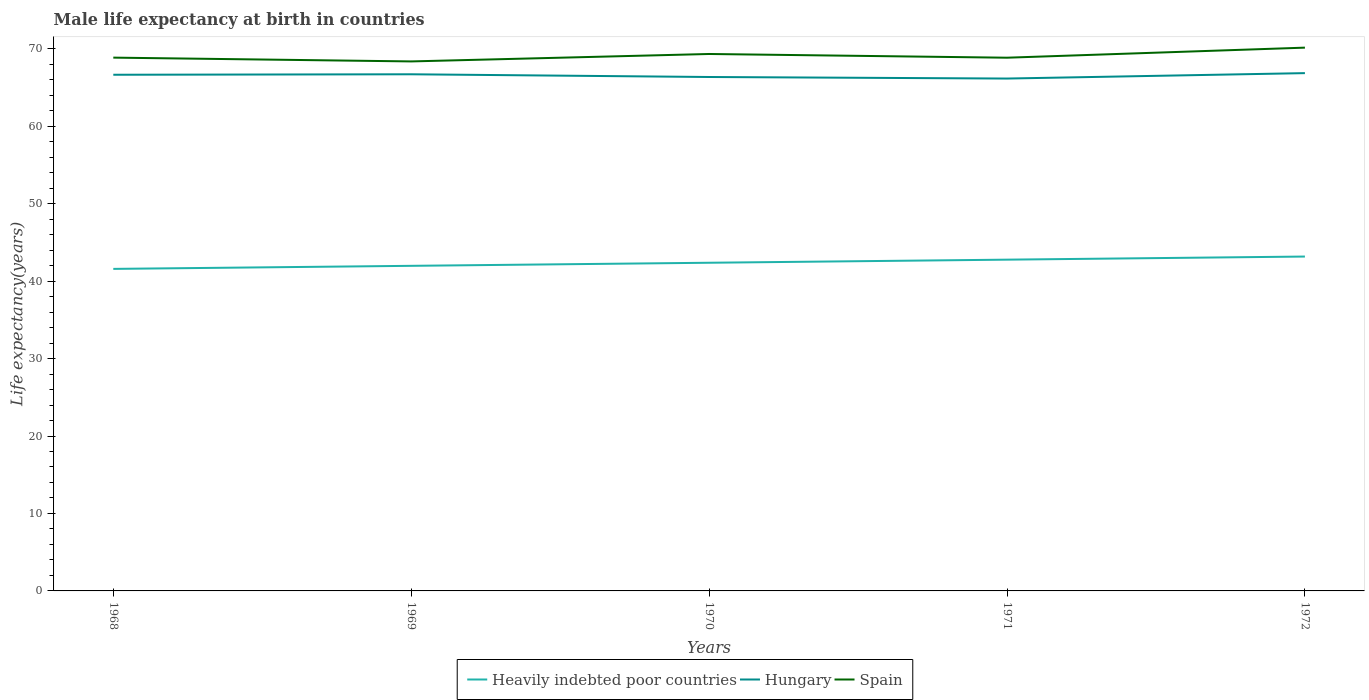Is the number of lines equal to the number of legend labels?
Make the answer very short. Yes. Across all years, what is the maximum male life expectancy at birth in Spain?
Offer a very short reply. 68.36. In which year was the male life expectancy at birth in Heavily indebted poor countries maximum?
Make the answer very short. 1968. What is the total male life expectancy at birth in Hungary in the graph?
Offer a very short reply. -0.15. What is the difference between the highest and the second highest male life expectancy at birth in Heavily indebted poor countries?
Keep it short and to the point. 1.59. What is the difference between the highest and the lowest male life expectancy at birth in Spain?
Provide a short and direct response. 2. Is the male life expectancy at birth in Heavily indebted poor countries strictly greater than the male life expectancy at birth in Spain over the years?
Provide a short and direct response. Yes. How many lines are there?
Provide a short and direct response. 3. How many years are there in the graph?
Your answer should be compact. 5. What is the difference between two consecutive major ticks on the Y-axis?
Provide a succinct answer. 10. Does the graph contain any zero values?
Your answer should be compact. No. Does the graph contain grids?
Give a very brief answer. No. Where does the legend appear in the graph?
Ensure brevity in your answer.  Bottom center. How many legend labels are there?
Offer a very short reply. 3. What is the title of the graph?
Keep it short and to the point. Male life expectancy at birth in countries. Does "Euro area" appear as one of the legend labels in the graph?
Keep it short and to the point. No. What is the label or title of the Y-axis?
Provide a succinct answer. Life expectancy(years). What is the Life expectancy(years) in Heavily indebted poor countries in 1968?
Make the answer very short. 41.58. What is the Life expectancy(years) in Hungary in 1968?
Provide a succinct answer. 66.64. What is the Life expectancy(years) in Spain in 1968?
Ensure brevity in your answer.  68.85. What is the Life expectancy(years) of Heavily indebted poor countries in 1969?
Make the answer very short. 41.97. What is the Life expectancy(years) in Hungary in 1969?
Your answer should be very brief. 66.7. What is the Life expectancy(years) of Spain in 1969?
Your answer should be very brief. 68.36. What is the Life expectancy(years) of Heavily indebted poor countries in 1970?
Provide a succinct answer. 42.37. What is the Life expectancy(years) of Hungary in 1970?
Ensure brevity in your answer.  66.35. What is the Life expectancy(years) in Spain in 1970?
Keep it short and to the point. 69.32. What is the Life expectancy(years) of Heavily indebted poor countries in 1971?
Offer a very short reply. 42.77. What is the Life expectancy(years) in Hungary in 1971?
Ensure brevity in your answer.  66.15. What is the Life expectancy(years) in Spain in 1971?
Provide a short and direct response. 68.84. What is the Life expectancy(years) in Heavily indebted poor countries in 1972?
Make the answer very short. 43.17. What is the Life expectancy(years) of Hungary in 1972?
Your answer should be compact. 66.85. What is the Life expectancy(years) of Spain in 1972?
Make the answer very short. 70.14. Across all years, what is the maximum Life expectancy(years) in Heavily indebted poor countries?
Provide a short and direct response. 43.17. Across all years, what is the maximum Life expectancy(years) of Hungary?
Make the answer very short. 66.85. Across all years, what is the maximum Life expectancy(years) of Spain?
Offer a very short reply. 70.14. Across all years, what is the minimum Life expectancy(years) in Heavily indebted poor countries?
Offer a terse response. 41.58. Across all years, what is the minimum Life expectancy(years) of Hungary?
Offer a terse response. 66.15. Across all years, what is the minimum Life expectancy(years) of Spain?
Give a very brief answer. 68.36. What is the total Life expectancy(years) of Heavily indebted poor countries in the graph?
Provide a short and direct response. 211.85. What is the total Life expectancy(years) of Hungary in the graph?
Your response must be concise. 332.69. What is the total Life expectancy(years) of Spain in the graph?
Ensure brevity in your answer.  345.51. What is the difference between the Life expectancy(years) in Heavily indebted poor countries in 1968 and that in 1969?
Give a very brief answer. -0.4. What is the difference between the Life expectancy(years) in Hungary in 1968 and that in 1969?
Keep it short and to the point. -0.06. What is the difference between the Life expectancy(years) in Spain in 1968 and that in 1969?
Your answer should be very brief. 0.49. What is the difference between the Life expectancy(years) of Heavily indebted poor countries in 1968 and that in 1970?
Offer a terse response. -0.79. What is the difference between the Life expectancy(years) of Hungary in 1968 and that in 1970?
Ensure brevity in your answer.  0.29. What is the difference between the Life expectancy(years) in Spain in 1968 and that in 1970?
Make the answer very short. -0.47. What is the difference between the Life expectancy(years) of Heavily indebted poor countries in 1968 and that in 1971?
Offer a very short reply. -1.19. What is the difference between the Life expectancy(years) of Hungary in 1968 and that in 1971?
Provide a succinct answer. 0.49. What is the difference between the Life expectancy(years) in Heavily indebted poor countries in 1968 and that in 1972?
Keep it short and to the point. -1.59. What is the difference between the Life expectancy(years) in Hungary in 1968 and that in 1972?
Give a very brief answer. -0.21. What is the difference between the Life expectancy(years) of Spain in 1968 and that in 1972?
Provide a succinct answer. -1.29. What is the difference between the Life expectancy(years) of Heavily indebted poor countries in 1969 and that in 1970?
Your response must be concise. -0.4. What is the difference between the Life expectancy(years) in Spain in 1969 and that in 1970?
Make the answer very short. -0.96. What is the difference between the Life expectancy(years) of Heavily indebted poor countries in 1969 and that in 1971?
Provide a short and direct response. -0.8. What is the difference between the Life expectancy(years) of Hungary in 1969 and that in 1971?
Give a very brief answer. 0.55. What is the difference between the Life expectancy(years) of Spain in 1969 and that in 1971?
Make the answer very short. -0.48. What is the difference between the Life expectancy(years) in Heavily indebted poor countries in 1969 and that in 1972?
Your response must be concise. -1.2. What is the difference between the Life expectancy(years) in Hungary in 1969 and that in 1972?
Your response must be concise. -0.15. What is the difference between the Life expectancy(years) of Spain in 1969 and that in 1972?
Offer a terse response. -1.78. What is the difference between the Life expectancy(years) of Heavily indebted poor countries in 1970 and that in 1971?
Keep it short and to the point. -0.4. What is the difference between the Life expectancy(years) of Spain in 1970 and that in 1971?
Your answer should be very brief. 0.48. What is the difference between the Life expectancy(years) in Heavily indebted poor countries in 1970 and that in 1972?
Give a very brief answer. -0.8. What is the difference between the Life expectancy(years) in Hungary in 1970 and that in 1972?
Ensure brevity in your answer.  -0.5. What is the difference between the Life expectancy(years) in Spain in 1970 and that in 1972?
Your answer should be compact. -0.82. What is the difference between the Life expectancy(years) of Heavily indebted poor countries in 1971 and that in 1972?
Offer a very short reply. -0.4. What is the difference between the Life expectancy(years) in Spain in 1971 and that in 1972?
Your response must be concise. -1.3. What is the difference between the Life expectancy(years) of Heavily indebted poor countries in 1968 and the Life expectancy(years) of Hungary in 1969?
Your response must be concise. -25.12. What is the difference between the Life expectancy(years) of Heavily indebted poor countries in 1968 and the Life expectancy(years) of Spain in 1969?
Make the answer very short. -26.78. What is the difference between the Life expectancy(years) of Hungary in 1968 and the Life expectancy(years) of Spain in 1969?
Offer a terse response. -1.72. What is the difference between the Life expectancy(years) of Heavily indebted poor countries in 1968 and the Life expectancy(years) of Hungary in 1970?
Provide a short and direct response. -24.77. What is the difference between the Life expectancy(years) of Heavily indebted poor countries in 1968 and the Life expectancy(years) of Spain in 1970?
Provide a short and direct response. -27.74. What is the difference between the Life expectancy(years) of Hungary in 1968 and the Life expectancy(years) of Spain in 1970?
Your answer should be compact. -2.68. What is the difference between the Life expectancy(years) of Heavily indebted poor countries in 1968 and the Life expectancy(years) of Hungary in 1971?
Keep it short and to the point. -24.57. What is the difference between the Life expectancy(years) in Heavily indebted poor countries in 1968 and the Life expectancy(years) in Spain in 1971?
Keep it short and to the point. -27.26. What is the difference between the Life expectancy(years) of Hungary in 1968 and the Life expectancy(years) of Spain in 1971?
Keep it short and to the point. -2.2. What is the difference between the Life expectancy(years) of Heavily indebted poor countries in 1968 and the Life expectancy(years) of Hungary in 1972?
Offer a terse response. -25.27. What is the difference between the Life expectancy(years) of Heavily indebted poor countries in 1968 and the Life expectancy(years) of Spain in 1972?
Provide a succinct answer. -28.56. What is the difference between the Life expectancy(years) in Hungary in 1968 and the Life expectancy(years) in Spain in 1972?
Ensure brevity in your answer.  -3.5. What is the difference between the Life expectancy(years) in Heavily indebted poor countries in 1969 and the Life expectancy(years) in Hungary in 1970?
Offer a terse response. -24.38. What is the difference between the Life expectancy(years) of Heavily indebted poor countries in 1969 and the Life expectancy(years) of Spain in 1970?
Your response must be concise. -27.35. What is the difference between the Life expectancy(years) of Hungary in 1969 and the Life expectancy(years) of Spain in 1970?
Your answer should be very brief. -2.62. What is the difference between the Life expectancy(years) in Heavily indebted poor countries in 1969 and the Life expectancy(years) in Hungary in 1971?
Make the answer very short. -24.18. What is the difference between the Life expectancy(years) of Heavily indebted poor countries in 1969 and the Life expectancy(years) of Spain in 1971?
Your response must be concise. -26.87. What is the difference between the Life expectancy(years) in Hungary in 1969 and the Life expectancy(years) in Spain in 1971?
Provide a short and direct response. -2.14. What is the difference between the Life expectancy(years) of Heavily indebted poor countries in 1969 and the Life expectancy(years) of Hungary in 1972?
Make the answer very short. -24.88. What is the difference between the Life expectancy(years) in Heavily indebted poor countries in 1969 and the Life expectancy(years) in Spain in 1972?
Your answer should be compact. -28.17. What is the difference between the Life expectancy(years) of Hungary in 1969 and the Life expectancy(years) of Spain in 1972?
Offer a very short reply. -3.44. What is the difference between the Life expectancy(years) in Heavily indebted poor countries in 1970 and the Life expectancy(years) in Hungary in 1971?
Give a very brief answer. -23.78. What is the difference between the Life expectancy(years) of Heavily indebted poor countries in 1970 and the Life expectancy(years) of Spain in 1971?
Provide a short and direct response. -26.47. What is the difference between the Life expectancy(years) in Hungary in 1970 and the Life expectancy(years) in Spain in 1971?
Offer a very short reply. -2.49. What is the difference between the Life expectancy(years) in Heavily indebted poor countries in 1970 and the Life expectancy(years) in Hungary in 1972?
Provide a succinct answer. -24.48. What is the difference between the Life expectancy(years) of Heavily indebted poor countries in 1970 and the Life expectancy(years) of Spain in 1972?
Provide a succinct answer. -27.77. What is the difference between the Life expectancy(years) of Hungary in 1970 and the Life expectancy(years) of Spain in 1972?
Provide a short and direct response. -3.79. What is the difference between the Life expectancy(years) in Heavily indebted poor countries in 1971 and the Life expectancy(years) in Hungary in 1972?
Ensure brevity in your answer.  -24.08. What is the difference between the Life expectancy(years) in Heavily indebted poor countries in 1971 and the Life expectancy(years) in Spain in 1972?
Give a very brief answer. -27.37. What is the difference between the Life expectancy(years) of Hungary in 1971 and the Life expectancy(years) of Spain in 1972?
Your answer should be very brief. -3.99. What is the average Life expectancy(years) of Heavily indebted poor countries per year?
Ensure brevity in your answer.  42.37. What is the average Life expectancy(years) of Hungary per year?
Offer a terse response. 66.54. What is the average Life expectancy(years) in Spain per year?
Your response must be concise. 69.1. In the year 1968, what is the difference between the Life expectancy(years) in Heavily indebted poor countries and Life expectancy(years) in Hungary?
Provide a succinct answer. -25.06. In the year 1968, what is the difference between the Life expectancy(years) in Heavily indebted poor countries and Life expectancy(years) in Spain?
Offer a terse response. -27.27. In the year 1968, what is the difference between the Life expectancy(years) of Hungary and Life expectancy(years) of Spain?
Your answer should be compact. -2.21. In the year 1969, what is the difference between the Life expectancy(years) in Heavily indebted poor countries and Life expectancy(years) in Hungary?
Provide a short and direct response. -24.73. In the year 1969, what is the difference between the Life expectancy(years) in Heavily indebted poor countries and Life expectancy(years) in Spain?
Your response must be concise. -26.39. In the year 1969, what is the difference between the Life expectancy(years) in Hungary and Life expectancy(years) in Spain?
Provide a short and direct response. -1.66. In the year 1970, what is the difference between the Life expectancy(years) of Heavily indebted poor countries and Life expectancy(years) of Hungary?
Give a very brief answer. -23.98. In the year 1970, what is the difference between the Life expectancy(years) of Heavily indebted poor countries and Life expectancy(years) of Spain?
Your answer should be compact. -26.95. In the year 1970, what is the difference between the Life expectancy(years) in Hungary and Life expectancy(years) in Spain?
Your answer should be very brief. -2.97. In the year 1971, what is the difference between the Life expectancy(years) of Heavily indebted poor countries and Life expectancy(years) of Hungary?
Give a very brief answer. -23.38. In the year 1971, what is the difference between the Life expectancy(years) of Heavily indebted poor countries and Life expectancy(years) of Spain?
Offer a very short reply. -26.07. In the year 1971, what is the difference between the Life expectancy(years) of Hungary and Life expectancy(years) of Spain?
Your answer should be very brief. -2.69. In the year 1972, what is the difference between the Life expectancy(years) of Heavily indebted poor countries and Life expectancy(years) of Hungary?
Offer a very short reply. -23.68. In the year 1972, what is the difference between the Life expectancy(years) in Heavily indebted poor countries and Life expectancy(years) in Spain?
Your response must be concise. -26.97. In the year 1972, what is the difference between the Life expectancy(years) of Hungary and Life expectancy(years) of Spain?
Your answer should be compact. -3.29. What is the ratio of the Life expectancy(years) of Heavily indebted poor countries in 1968 to that in 1969?
Provide a succinct answer. 0.99. What is the ratio of the Life expectancy(years) of Spain in 1968 to that in 1969?
Give a very brief answer. 1.01. What is the ratio of the Life expectancy(years) of Heavily indebted poor countries in 1968 to that in 1970?
Provide a succinct answer. 0.98. What is the ratio of the Life expectancy(years) of Hungary in 1968 to that in 1970?
Give a very brief answer. 1. What is the ratio of the Life expectancy(years) in Heavily indebted poor countries in 1968 to that in 1971?
Provide a short and direct response. 0.97. What is the ratio of the Life expectancy(years) in Hungary in 1968 to that in 1971?
Give a very brief answer. 1.01. What is the ratio of the Life expectancy(years) in Heavily indebted poor countries in 1968 to that in 1972?
Make the answer very short. 0.96. What is the ratio of the Life expectancy(years) in Hungary in 1968 to that in 1972?
Provide a short and direct response. 1. What is the ratio of the Life expectancy(years) of Spain in 1968 to that in 1972?
Ensure brevity in your answer.  0.98. What is the ratio of the Life expectancy(years) in Heavily indebted poor countries in 1969 to that in 1970?
Provide a short and direct response. 0.99. What is the ratio of the Life expectancy(years) of Spain in 1969 to that in 1970?
Make the answer very short. 0.99. What is the ratio of the Life expectancy(years) in Heavily indebted poor countries in 1969 to that in 1971?
Keep it short and to the point. 0.98. What is the ratio of the Life expectancy(years) in Hungary in 1969 to that in 1971?
Give a very brief answer. 1.01. What is the ratio of the Life expectancy(years) in Spain in 1969 to that in 1971?
Offer a terse response. 0.99. What is the ratio of the Life expectancy(years) of Heavily indebted poor countries in 1969 to that in 1972?
Offer a terse response. 0.97. What is the ratio of the Life expectancy(years) in Hungary in 1969 to that in 1972?
Your response must be concise. 1. What is the ratio of the Life expectancy(years) of Spain in 1969 to that in 1972?
Keep it short and to the point. 0.97. What is the ratio of the Life expectancy(years) of Heavily indebted poor countries in 1970 to that in 1971?
Give a very brief answer. 0.99. What is the ratio of the Life expectancy(years) in Hungary in 1970 to that in 1971?
Keep it short and to the point. 1. What is the ratio of the Life expectancy(years) of Spain in 1970 to that in 1971?
Offer a terse response. 1.01. What is the ratio of the Life expectancy(years) of Heavily indebted poor countries in 1970 to that in 1972?
Offer a very short reply. 0.98. What is the ratio of the Life expectancy(years) in Hungary in 1970 to that in 1972?
Your answer should be very brief. 0.99. What is the ratio of the Life expectancy(years) of Spain in 1970 to that in 1972?
Offer a very short reply. 0.99. What is the ratio of the Life expectancy(years) in Heavily indebted poor countries in 1971 to that in 1972?
Keep it short and to the point. 0.99. What is the ratio of the Life expectancy(years) in Spain in 1971 to that in 1972?
Your response must be concise. 0.98. What is the difference between the highest and the second highest Life expectancy(years) of Heavily indebted poor countries?
Give a very brief answer. 0.4. What is the difference between the highest and the second highest Life expectancy(years) in Hungary?
Provide a short and direct response. 0.15. What is the difference between the highest and the second highest Life expectancy(years) of Spain?
Provide a short and direct response. 0.82. What is the difference between the highest and the lowest Life expectancy(years) of Heavily indebted poor countries?
Make the answer very short. 1.59. What is the difference between the highest and the lowest Life expectancy(years) of Spain?
Offer a very short reply. 1.78. 